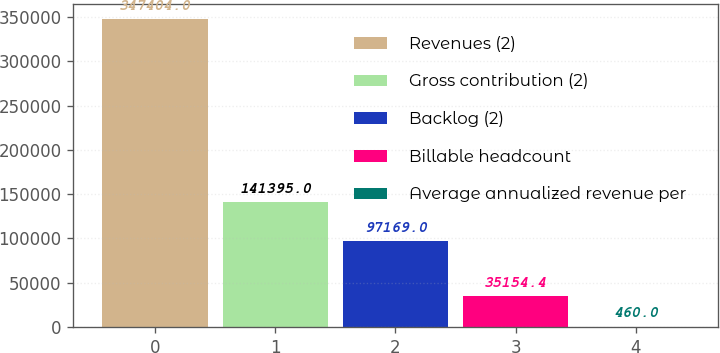Convert chart. <chart><loc_0><loc_0><loc_500><loc_500><bar_chart><fcel>Revenues (2)<fcel>Gross contribution (2)<fcel>Backlog (2)<fcel>Billable headcount<fcel>Average annualized revenue per<nl><fcel>347404<fcel>141395<fcel>97169<fcel>35154.4<fcel>460<nl></chart> 